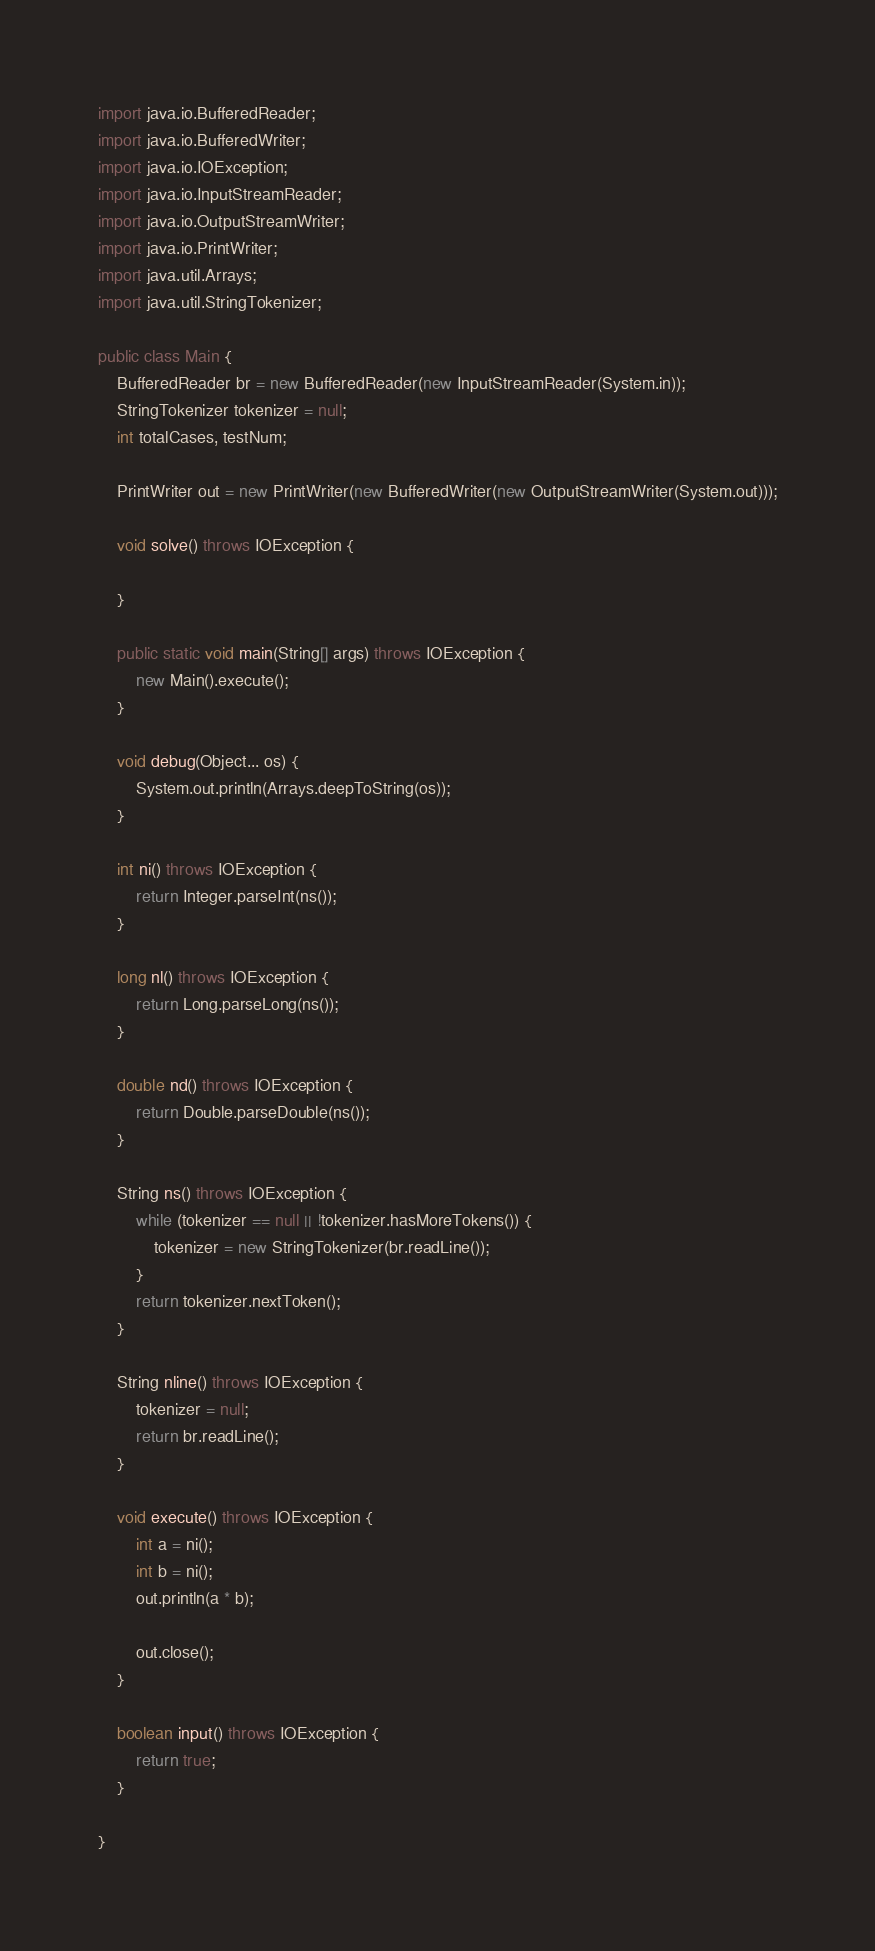<code> <loc_0><loc_0><loc_500><loc_500><_Java_>

import java.io.BufferedReader;
import java.io.BufferedWriter;
import java.io.IOException;
import java.io.InputStreamReader;
import java.io.OutputStreamWriter;
import java.io.PrintWriter;
import java.util.Arrays;
import java.util.StringTokenizer;

public class Main {
    BufferedReader br = new BufferedReader(new InputStreamReader(System.in));
    StringTokenizer tokenizer = null;
    int totalCases, testNum;

    PrintWriter out = new PrintWriter(new BufferedWriter(new OutputStreamWriter(System.out)));

    void solve() throws IOException {

    }

    public static void main(String[] args) throws IOException {
        new Main().execute();
    }

    void debug(Object... os) {
        System.out.println(Arrays.deepToString(os));
    }

    int ni() throws IOException {
        return Integer.parseInt(ns());
    }

    long nl() throws IOException {
        return Long.parseLong(ns());
    }

    double nd() throws IOException {
        return Double.parseDouble(ns());
    }

    String ns() throws IOException {
        while (tokenizer == null || !tokenizer.hasMoreTokens()) {
            tokenizer = new StringTokenizer(br.readLine());
        }
        return tokenizer.nextToken();
    }

    String nline() throws IOException {
        tokenizer = null;
        return br.readLine();
    }

    void execute() throws IOException {
        int a = ni();
        int b = ni();
        out.println(a * b);
        
        out.close();
    }

    boolean input() throws IOException {
        return true;
    }

}
</code> 